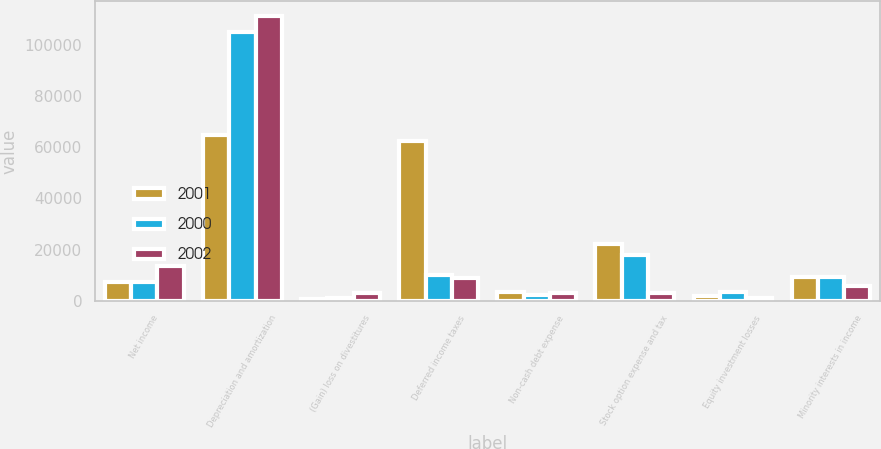<chart> <loc_0><loc_0><loc_500><loc_500><stacked_bar_chart><ecel><fcel>Net income<fcel>Depreciation and amortization<fcel>(Gain) loss on divestitures<fcel>Deferred income taxes<fcel>Non-cash debt expense<fcel>Stock option expense and tax<fcel>Equity investment losses<fcel>Minority interests in income<nl><fcel>2001<fcel>7424<fcel>64665<fcel>771<fcel>62468<fcel>3217<fcel>22212<fcel>1791<fcel>9299<nl><fcel>2000<fcel>7424<fcel>105209<fcel>1031<fcel>10093<fcel>2396<fcel>17754<fcel>3228<fcel>9260<nl><fcel>2002<fcel>13485<fcel>111605<fcel>2875<fcel>8906<fcel>3008<fcel>2908<fcel>931<fcel>5942<nl></chart> 